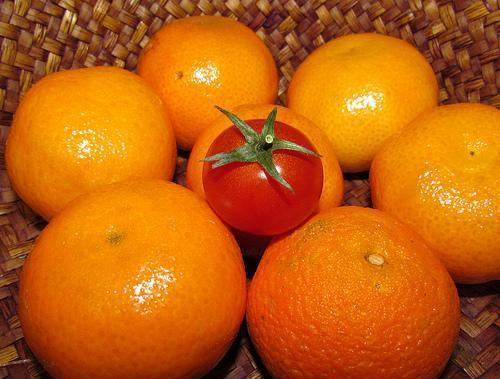How many oranges are there?
Give a very brief answer. 7. How many tomatoes are there?
Give a very brief answer. 1. 